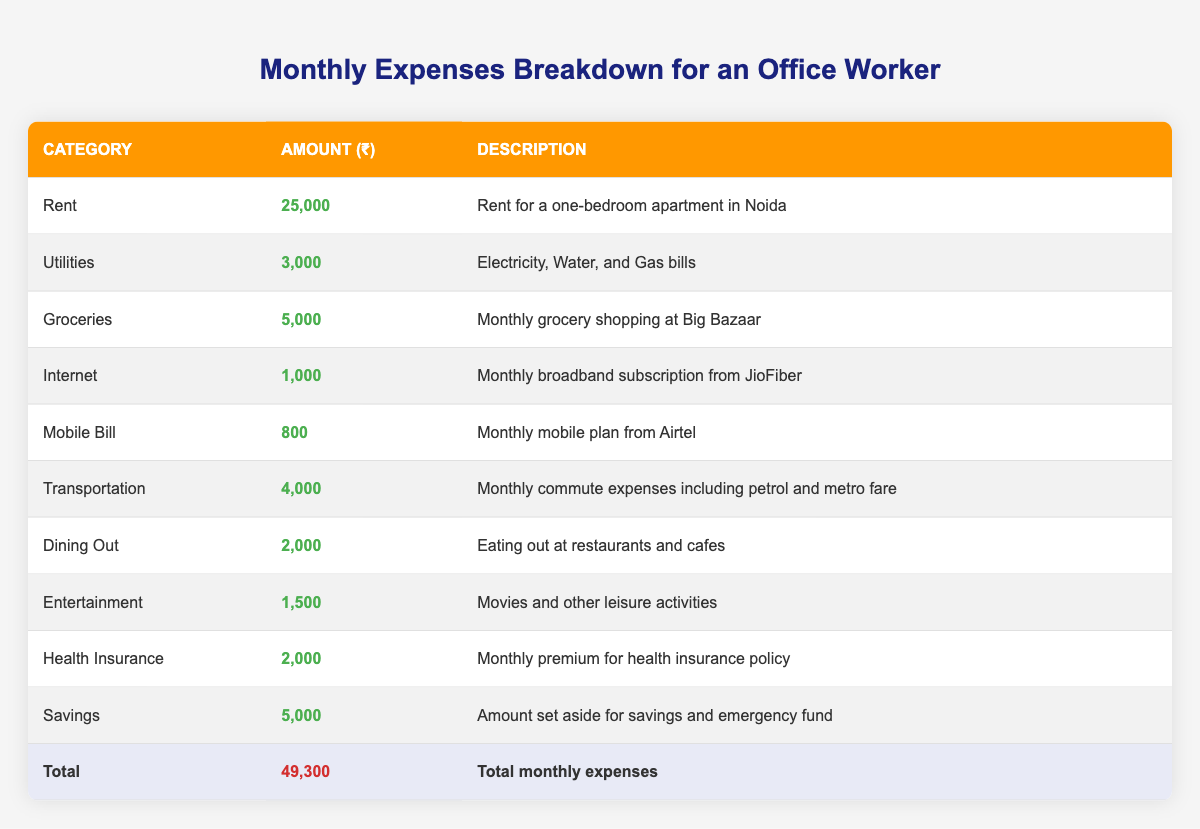What is the total amount spent on Rent and Utilities? The amount spent on Rent is 25,000, and for Utilities is 3,000. Summing these gives 25,000 + 3,000 = 28,000.
Answer: 28,000 How much is spent on Groceries compared to Internet? The amount spent on Groceries is 5,000, while for Internet it is 1,000. The difference is 5,000 - 1,000 = 4,000.
Answer: 4,000 Is the amount spent on Dining Out greater than the amount spent on Mobile Bill? The amount for Dining Out is 2,000, and for Mobile Bill, it is 800. Since 2,000 is greater than 800, the statement is true.
Answer: Yes What is the total amount spent on Entertainment and Dining Out? The amount for Entertainment is 1,500, and for Dining Out is 2,000. Adding these gives 1,500 + 2,000 = 3,500.
Answer: 3,500 What percentage of the total expenses is spent on Savings? Total monthly expenses amount to 49,300, and Saving amount is 5,000. The percentage is calculated as (5,000 / 49,300) * 100, which equals approximately 10.14%.
Answer: 10.14% How much more is spent on Transportation than on Mobile Bill? The amount spent on Transportation is 4,000, while the amount for Mobile Bill is 800. The difference is 4,000 - 800 = 3,200.
Answer: 3,200 What is the average amount spent per category? There are 10 categories, and the total expenses are 49,300. Dividing gives an average of 49,300 / 10 = 4,930.
Answer: 4,930 If the monthly utility bills increase by 10%, what will the new amount be? The current amount for Utilities is 3,000. A 10% increase is calculated as 3,000 * 0.10 = 300. Adding this to the original amount gives 3,000 + 300 = 3,300.
Answer: 3,300 How much is spent on Health Insurance and Dining Out combined? The amount for Health Insurance is 2,000, and for Dining Out it is 2,000. Combined, the total is 2,000 + 2,000 = 4,000.
Answer: 4,000 What is the total spent on Groceries, Health Insurance, and Internet? The amounts are 5,000 (Groceries), 2,000 (Health Insurance), and 1,000 (Internet). Adding these gives 5,000 + 2,000 + 1,000 = 8,000.
Answer: 8,000 